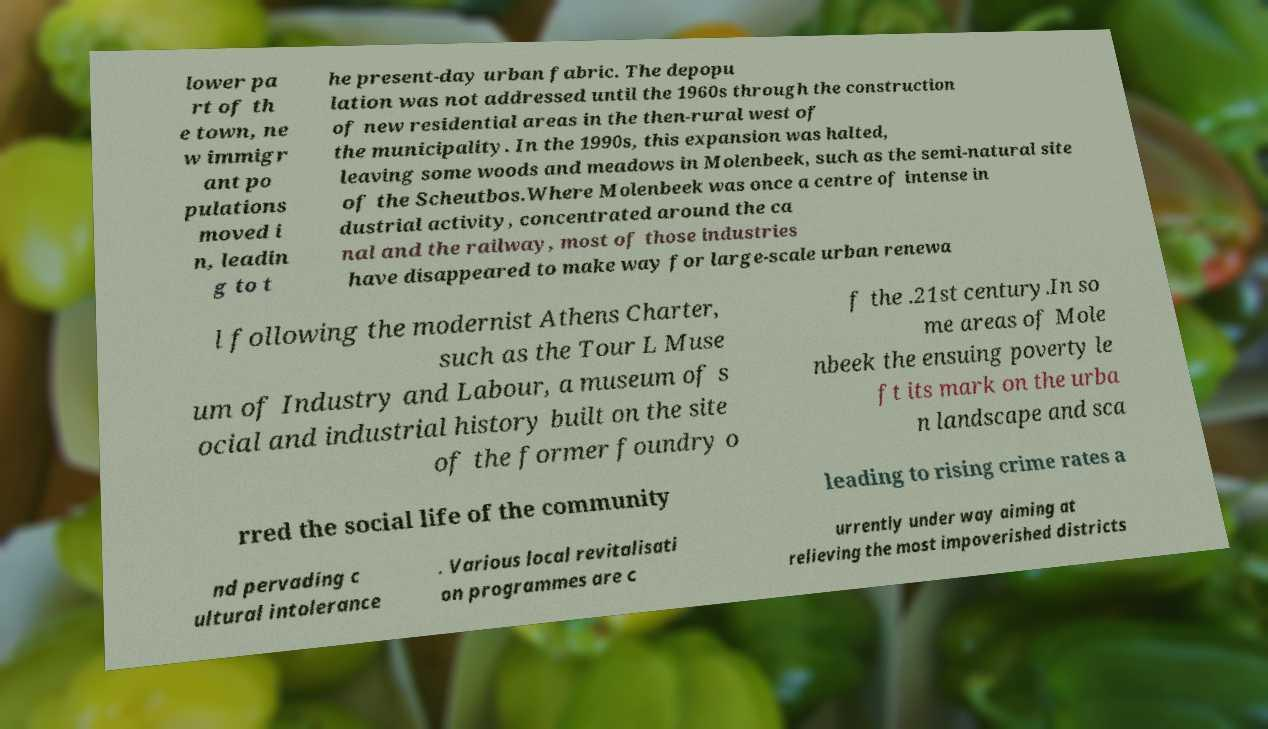Please read and relay the text visible in this image. What does it say? lower pa rt of th e town, ne w immigr ant po pulations moved i n, leadin g to t he present-day urban fabric. The depopu lation was not addressed until the 1960s through the construction of new residential areas in the then-rural west of the municipality. In the 1990s, this expansion was halted, leaving some woods and meadows in Molenbeek, such as the semi-natural site of the Scheutbos.Where Molenbeek was once a centre of intense in dustrial activity, concentrated around the ca nal and the railway, most of those industries have disappeared to make way for large-scale urban renewa l following the modernist Athens Charter, such as the Tour L Muse um of Industry and Labour, a museum of s ocial and industrial history built on the site of the former foundry o f the .21st century.In so me areas of Mole nbeek the ensuing poverty le ft its mark on the urba n landscape and sca rred the social life of the community leading to rising crime rates a nd pervading c ultural intolerance . Various local revitalisati on programmes are c urrently under way aiming at relieving the most impoverished districts 